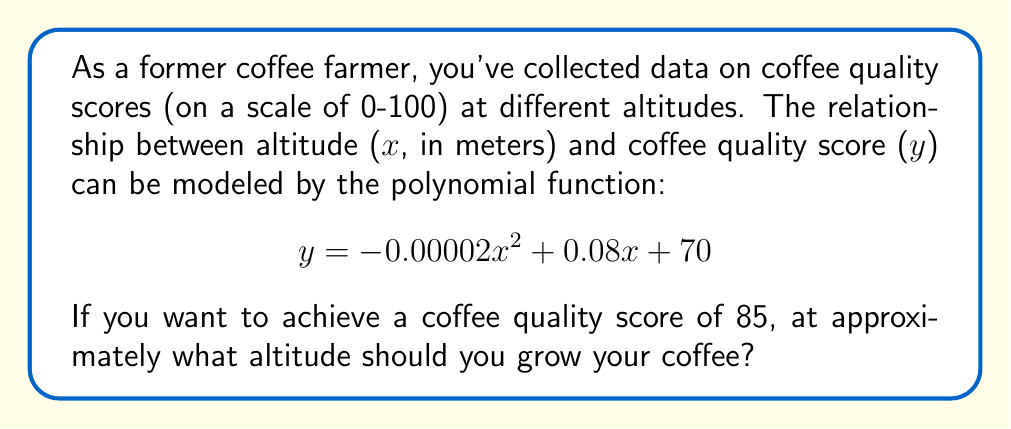Show me your answer to this math problem. To find the altitude that yields a coffee quality score of 85, we need to solve the equation:

$$85 = -0.00002x^2 + 0.08x + 70$$

Let's solve this step-by-step:

1) First, rearrange the equation to standard form:
   $$-0.00002x^2 + 0.08x + (70 - 85) = 0$$
   $$-0.00002x^2 + 0.08x - 15 = 0$$

2) This is a quadratic equation in the form $ax^2 + bx + c = 0$, where:
   $a = -0.00002$
   $b = 0.08$
   $c = -15$

3) We can solve this using the quadratic formula: $x = \frac{-b \pm \sqrt{b^2 - 4ac}}{2a}$

4) Let's substitute our values:
   $$x = \frac{-0.08 \pm \sqrt{0.08^2 - 4(-0.00002)(-15)}}{2(-0.00002)}$$

5) Simplify under the square root:
   $$x = \frac{-0.08 \pm \sqrt{0.0064 + 0.0012}}{-0.00004}$$
   $$x = \frac{-0.08 \pm \sqrt{0.0076}}{-0.00004}$$

6) Solve:
   $$x = \frac{-0.08 \pm 0.0871779}{-0.00004}$$

7) This gives us two solutions:
   $$x_1 = \frac{-0.08 + 0.0871779}{-0.00004} \approx 179.45 \text{ meters}$$
   $$x_2 = \frac{-0.08 - 0.0871779}{-0.00004} \approx 4179.45 \text{ meters}$$

8) Since coffee typically grows at higher altitudes, we choose the higher solution.

Therefore, to achieve a coffee quality score of 85, you should grow your coffee at approximately 4179 meters altitude.
Answer: 4179 meters 